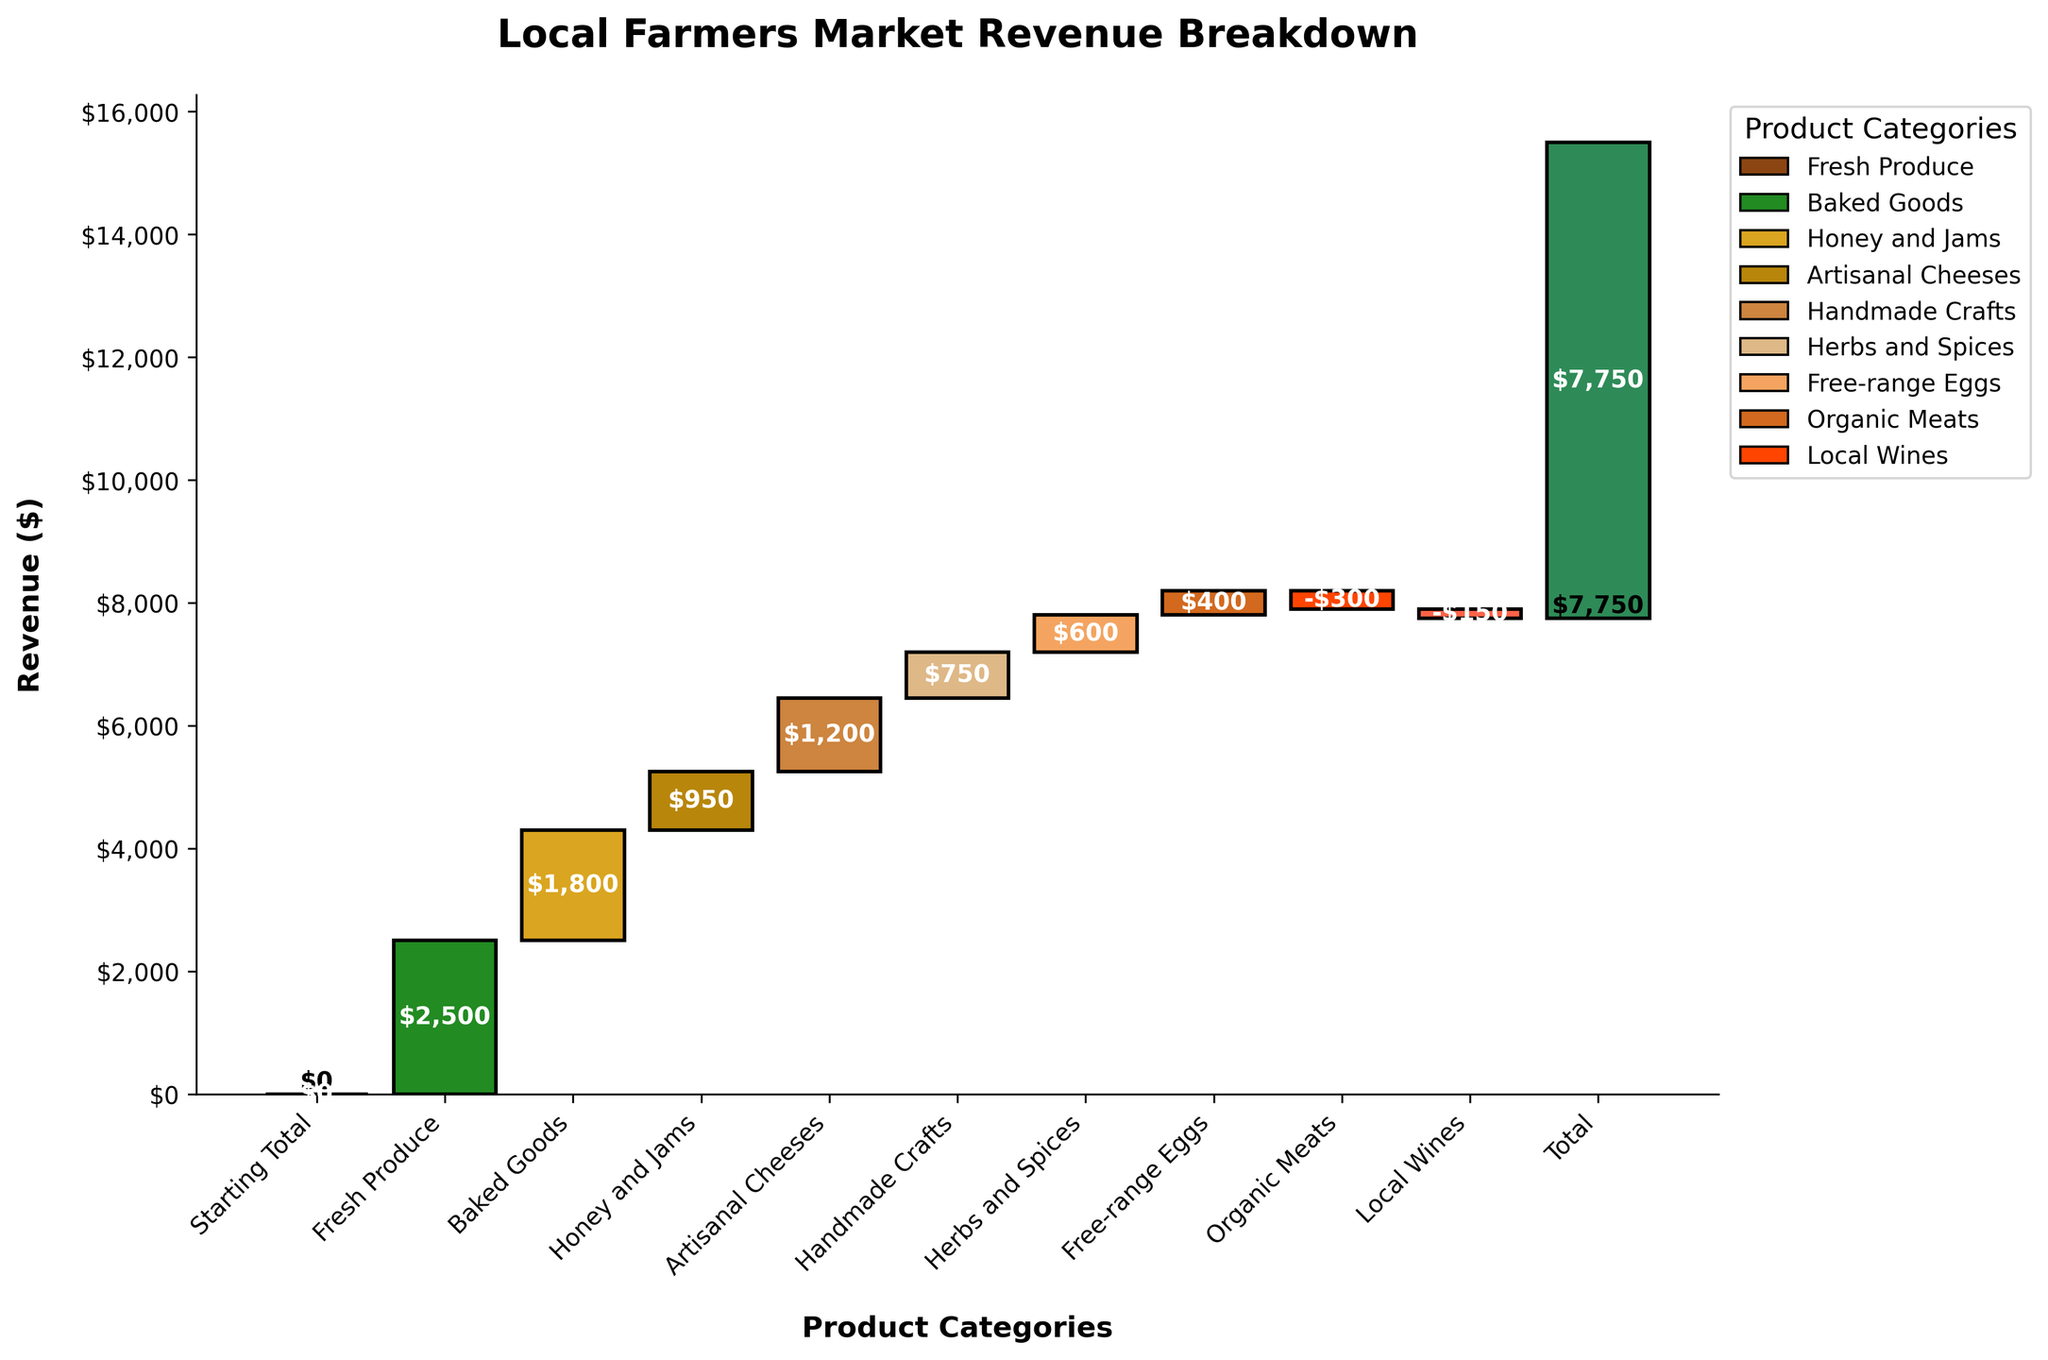What's the total revenue earned by the local farmers market? By looking at the highest point in the cumulative revenue at the end of the waterfall chart, you can see the total revenue earned by the local farmers market
Answer: $7,750 What product category contributed the most to the revenue? Identify the bar that represents the highest positive contribution on the chart, which is Fresh Produce
Answer: Fresh Produce Which categories have negative contributions to the total revenue? Look for the bars that go downwards from the baseline indicating negative contributions, which are Organic Meats and Local Wines
Answer: Organic Meats, Local Wines How much revenue did Fresh Produce contribute? By identifying the Fresh Produce bar, one can see its positive contribution from the label, which is $2,500
Answer: $2,500 What's the combined revenue contribution of Baked Goods and Artisanal Cheeses? The chart shows Baked Goods contributing $1,800 and Artisanal Cheeses contributing $1,200. Adding these gives $1,800 + $1,200
Answer: $3,000 How does the revenue from Handmade Crafts compare to that of Honey and Jams? By looking at the bars, Handmade Crafts contributed $750 and Honey and Jams contributed $950. Comparing the two, $750 < $950
Answer: Handmade Crafts is less Which product category had the lowest positive contribution to the revenue? Identify the smallest positive bar in the waterfall chart, representing Free-range Eggs with $400
Answer: Free-range Eggs How much more revenue did Herbs and Spices contribute compared to Free-range Eggs? Herbs and Spices contributed $600 while Free-range Eggs contributed $400. The difference is $600 - $400
Answer: $200 What is the combined contribution of categories with negative revenue? From the chart, Organic Meats has -$300 and Local Wines has -$150. The sum of these negative contributions is -$300 + (-$150)
Answer: -$450 What are the cumulative revenue values at the starting and ending points of the chart? At the start, the cumulative revenue is $0 (Starting Total). At the end, it's the Total Revenue value of $7,750 from the last bar
Answer: $0 and $7,750 